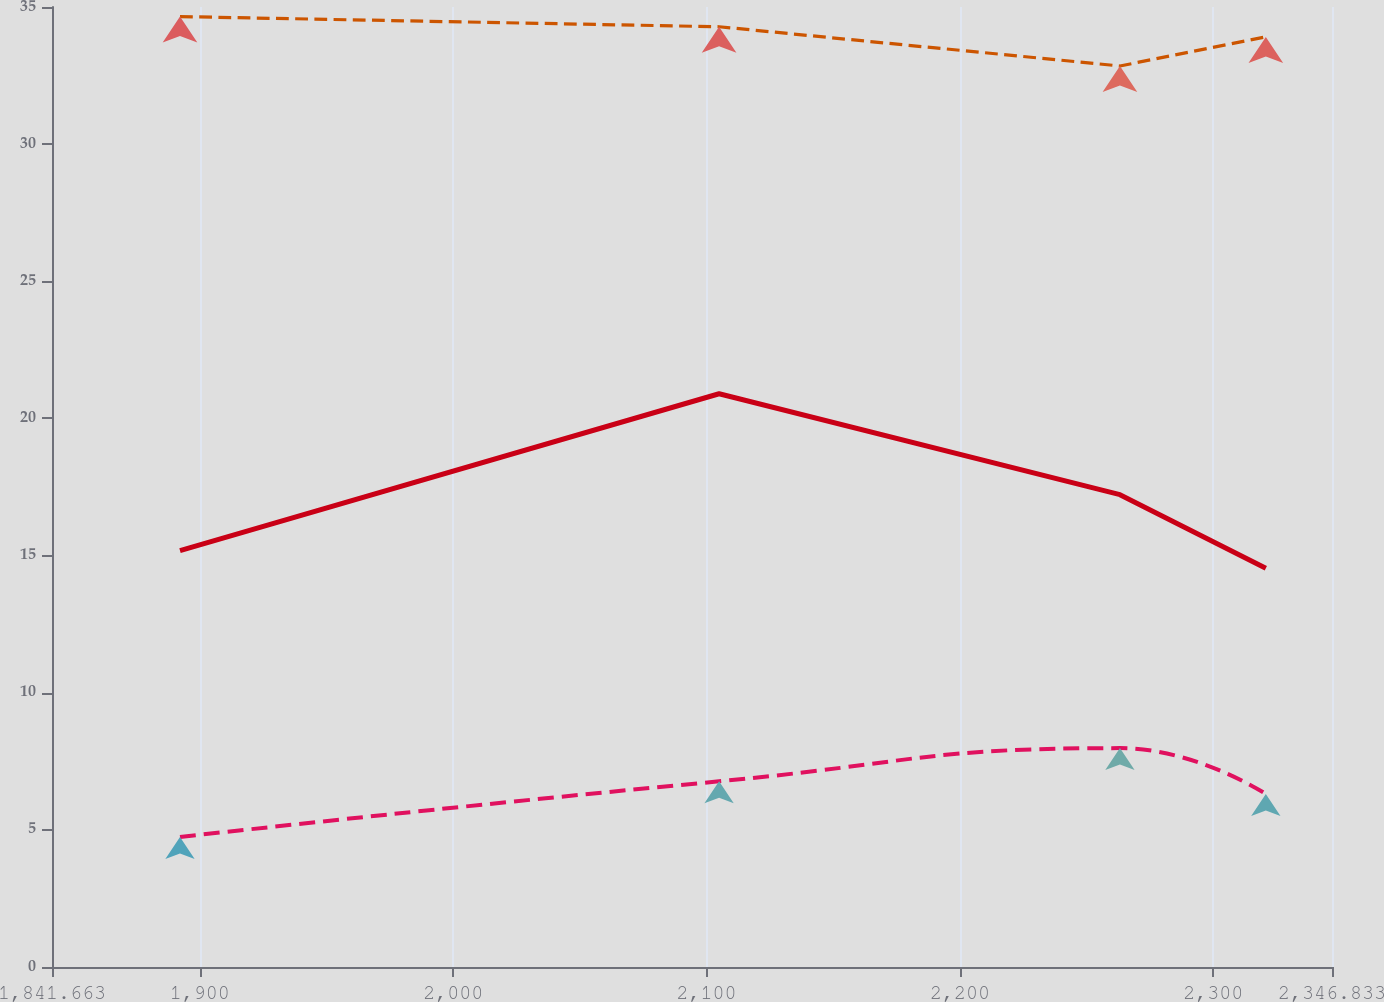Convert chart. <chart><loc_0><loc_0><loc_500><loc_500><line_chart><ecel><fcel>$ 21.4<fcel>$-<fcel>$ -<nl><fcel>1892.18<fcel>34.65<fcel>15.18<fcel>4.74<nl><fcel>2104.94<fcel>34.28<fcel>20.9<fcel>6.77<nl><fcel>2263.14<fcel>32.85<fcel>17.22<fcel>7.98<nl><fcel>2320.72<fcel>33.91<fcel>14.54<fcel>6.31<nl><fcel>2397.35<fcel>36.55<fcel>15.82<fcel>9.36<nl></chart> 